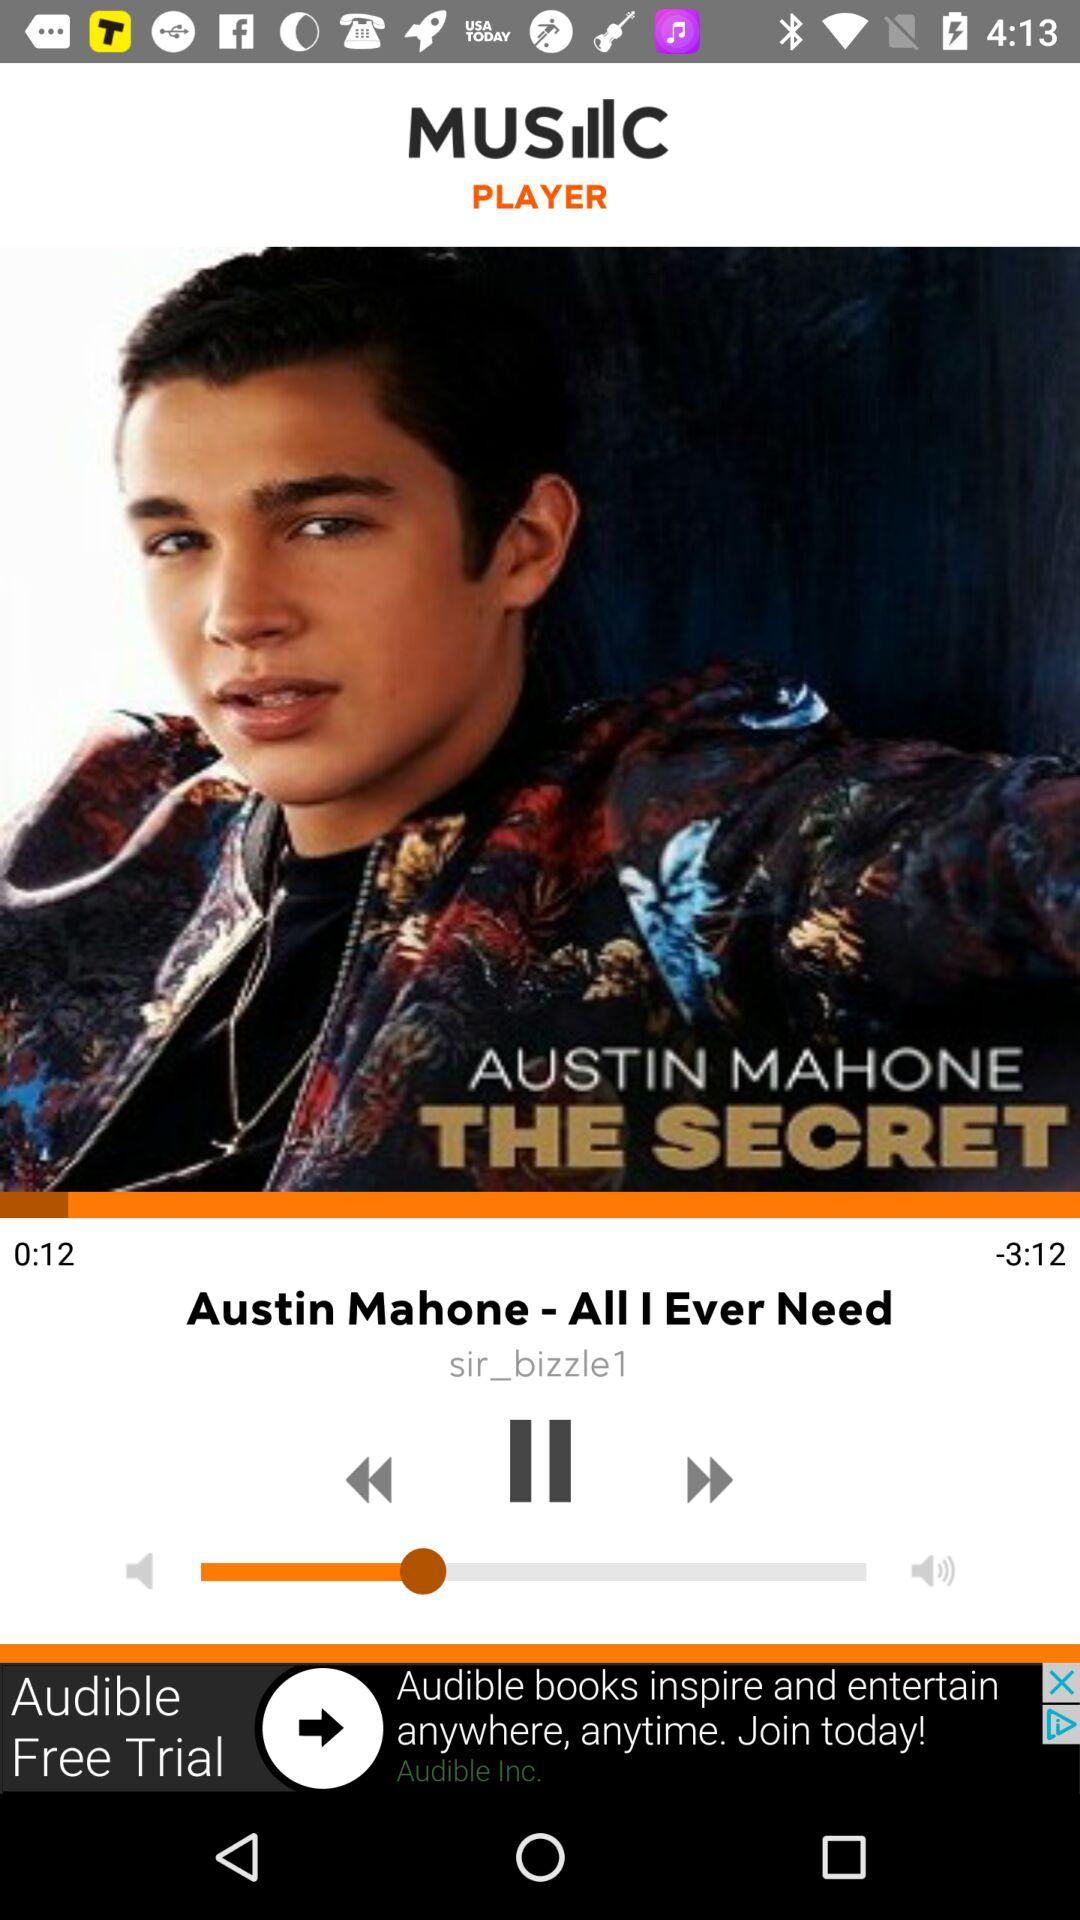What is the name of the song? The name of the song is "Austin Mahone - All I Ever Need". 